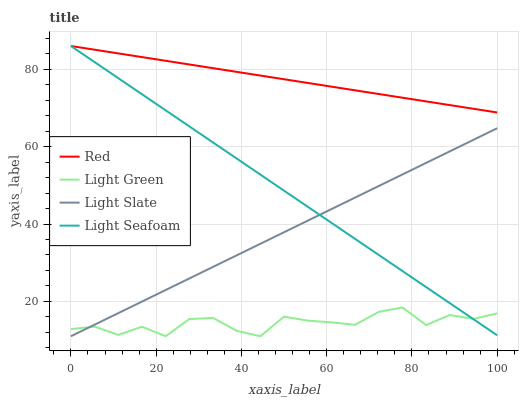Does Light Green have the minimum area under the curve?
Answer yes or no. Yes. Does Red have the maximum area under the curve?
Answer yes or no. Yes. Does Light Seafoam have the minimum area under the curve?
Answer yes or no. No. Does Light Seafoam have the maximum area under the curve?
Answer yes or no. No. Is Light Slate the smoothest?
Answer yes or no. Yes. Is Light Green the roughest?
Answer yes or no. Yes. Is Light Seafoam the smoothest?
Answer yes or no. No. Is Light Seafoam the roughest?
Answer yes or no. No. Does Light Slate have the lowest value?
Answer yes or no. Yes. Does Light Seafoam have the lowest value?
Answer yes or no. No. Does Red have the highest value?
Answer yes or no. Yes. Does Light Green have the highest value?
Answer yes or no. No. Is Light Green less than Red?
Answer yes or no. Yes. Is Red greater than Light Slate?
Answer yes or no. Yes. Does Light Seafoam intersect Light Slate?
Answer yes or no. Yes. Is Light Seafoam less than Light Slate?
Answer yes or no. No. Is Light Seafoam greater than Light Slate?
Answer yes or no. No. Does Light Green intersect Red?
Answer yes or no. No. 